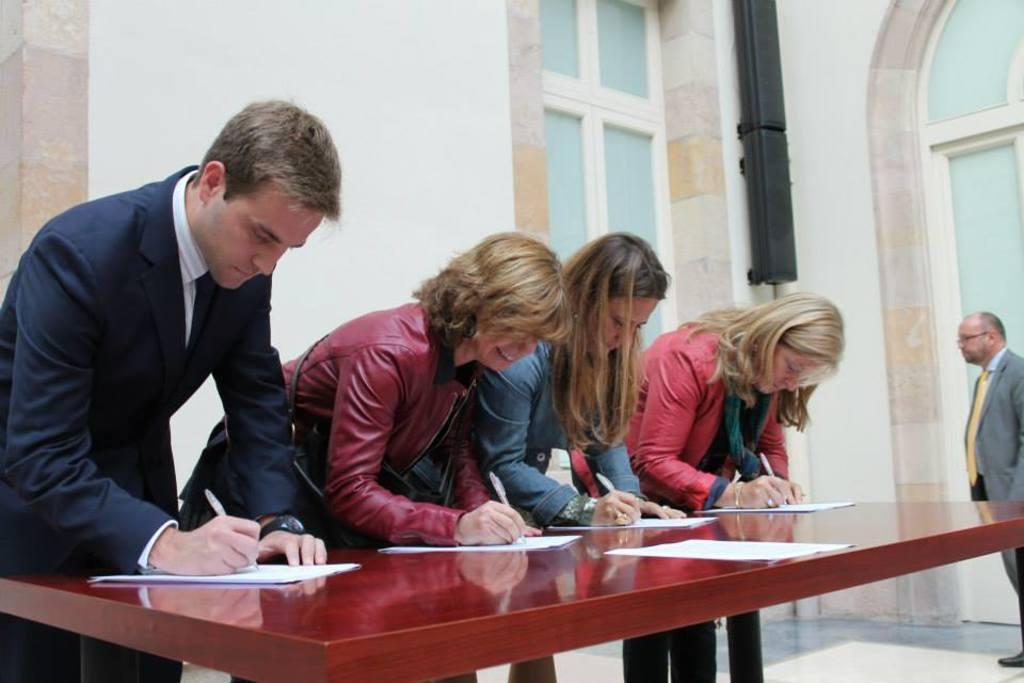Describe this image in one or two sentences. In this Image I see a man and 3 women who are holding the pens and there are papers in front of them and they are on the table. In the background I see the window and there is a man standing over here. 